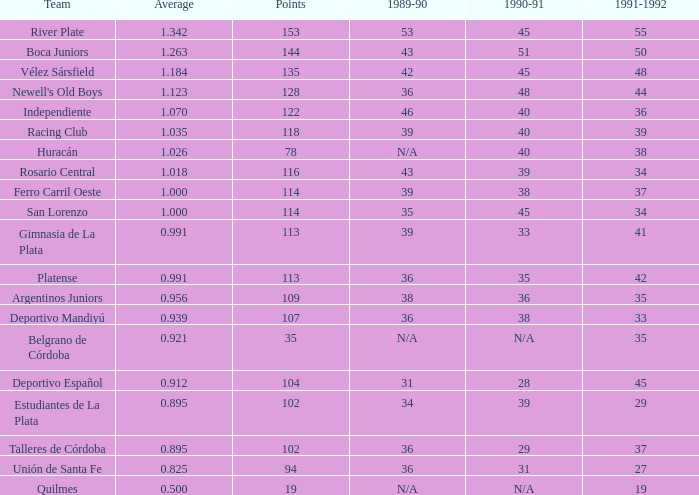What is the mean of a 1989-90 season with 36, a squad of talleres de córdoba, and a participation less than 114? 0.0. 